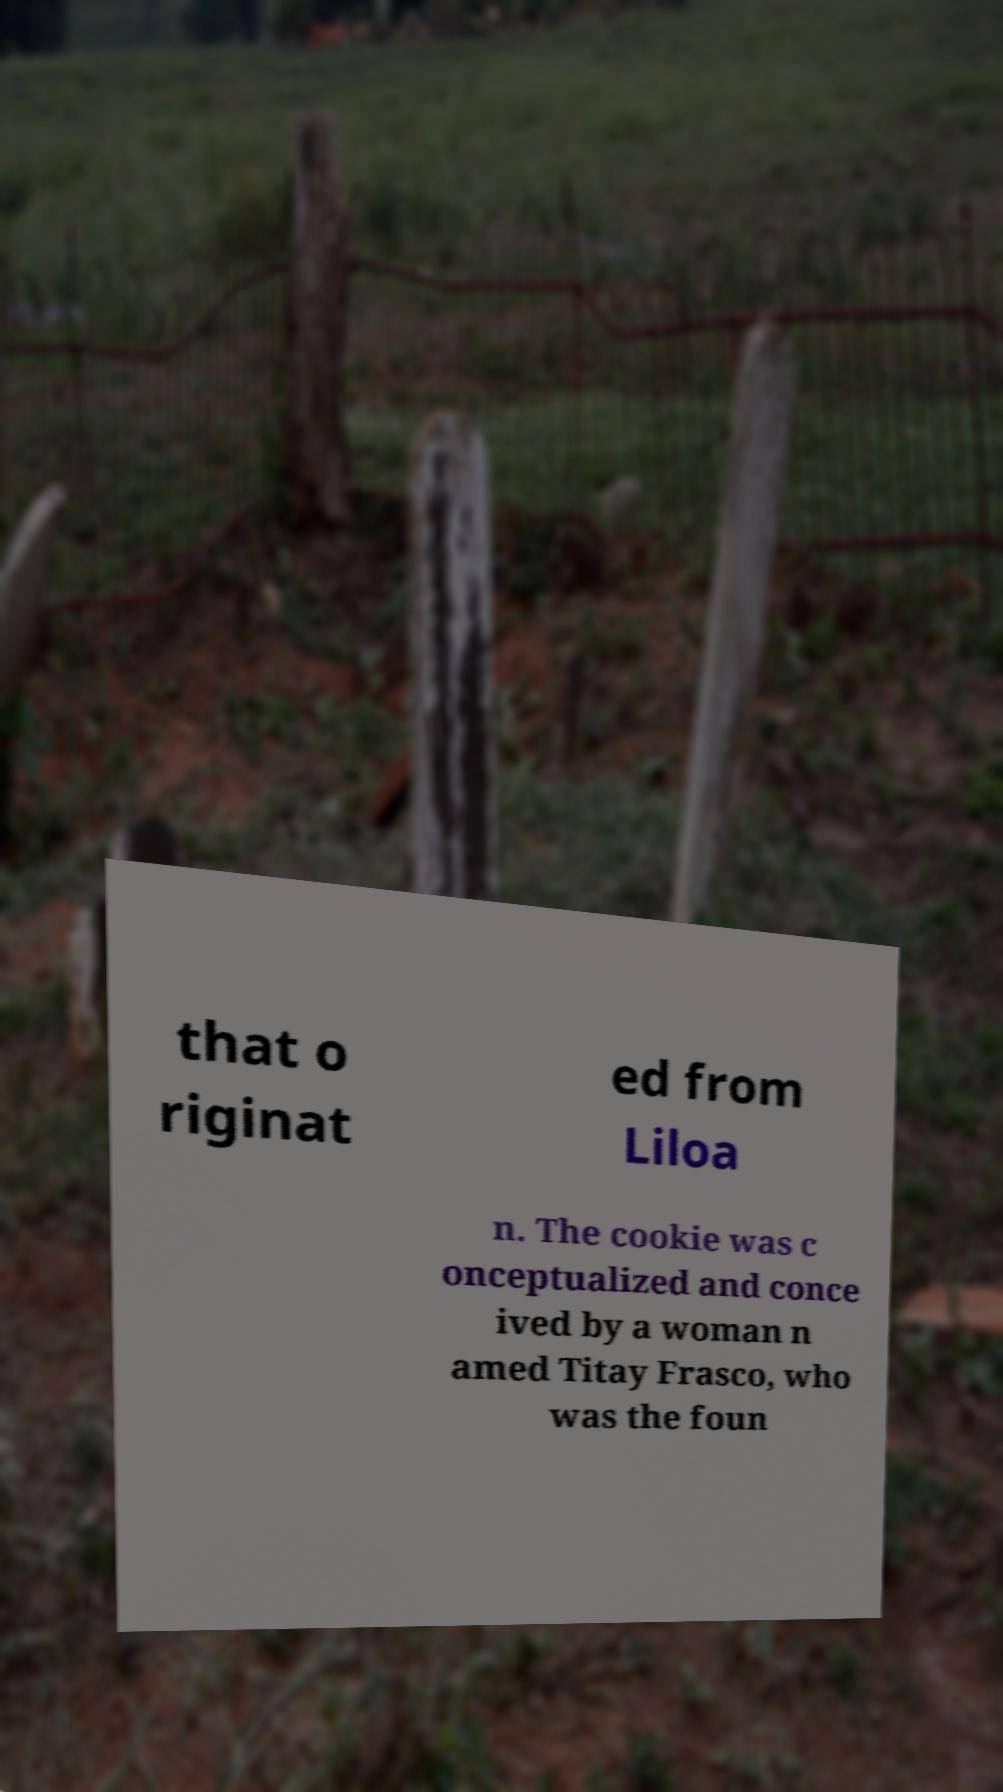There's text embedded in this image that I need extracted. Can you transcribe it verbatim? that o riginat ed from Liloa n. The cookie was c onceptualized and conce ived by a woman n amed Titay Frasco, who was the foun 